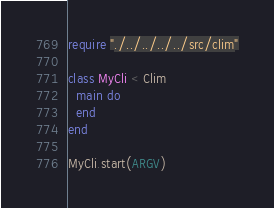<code> <loc_0><loc_0><loc_500><loc_500><_Crystal_>require "./../../../../src/clim"

class MyCli < Clim
  main do
  end
end

MyCli.start(ARGV)
</code> 